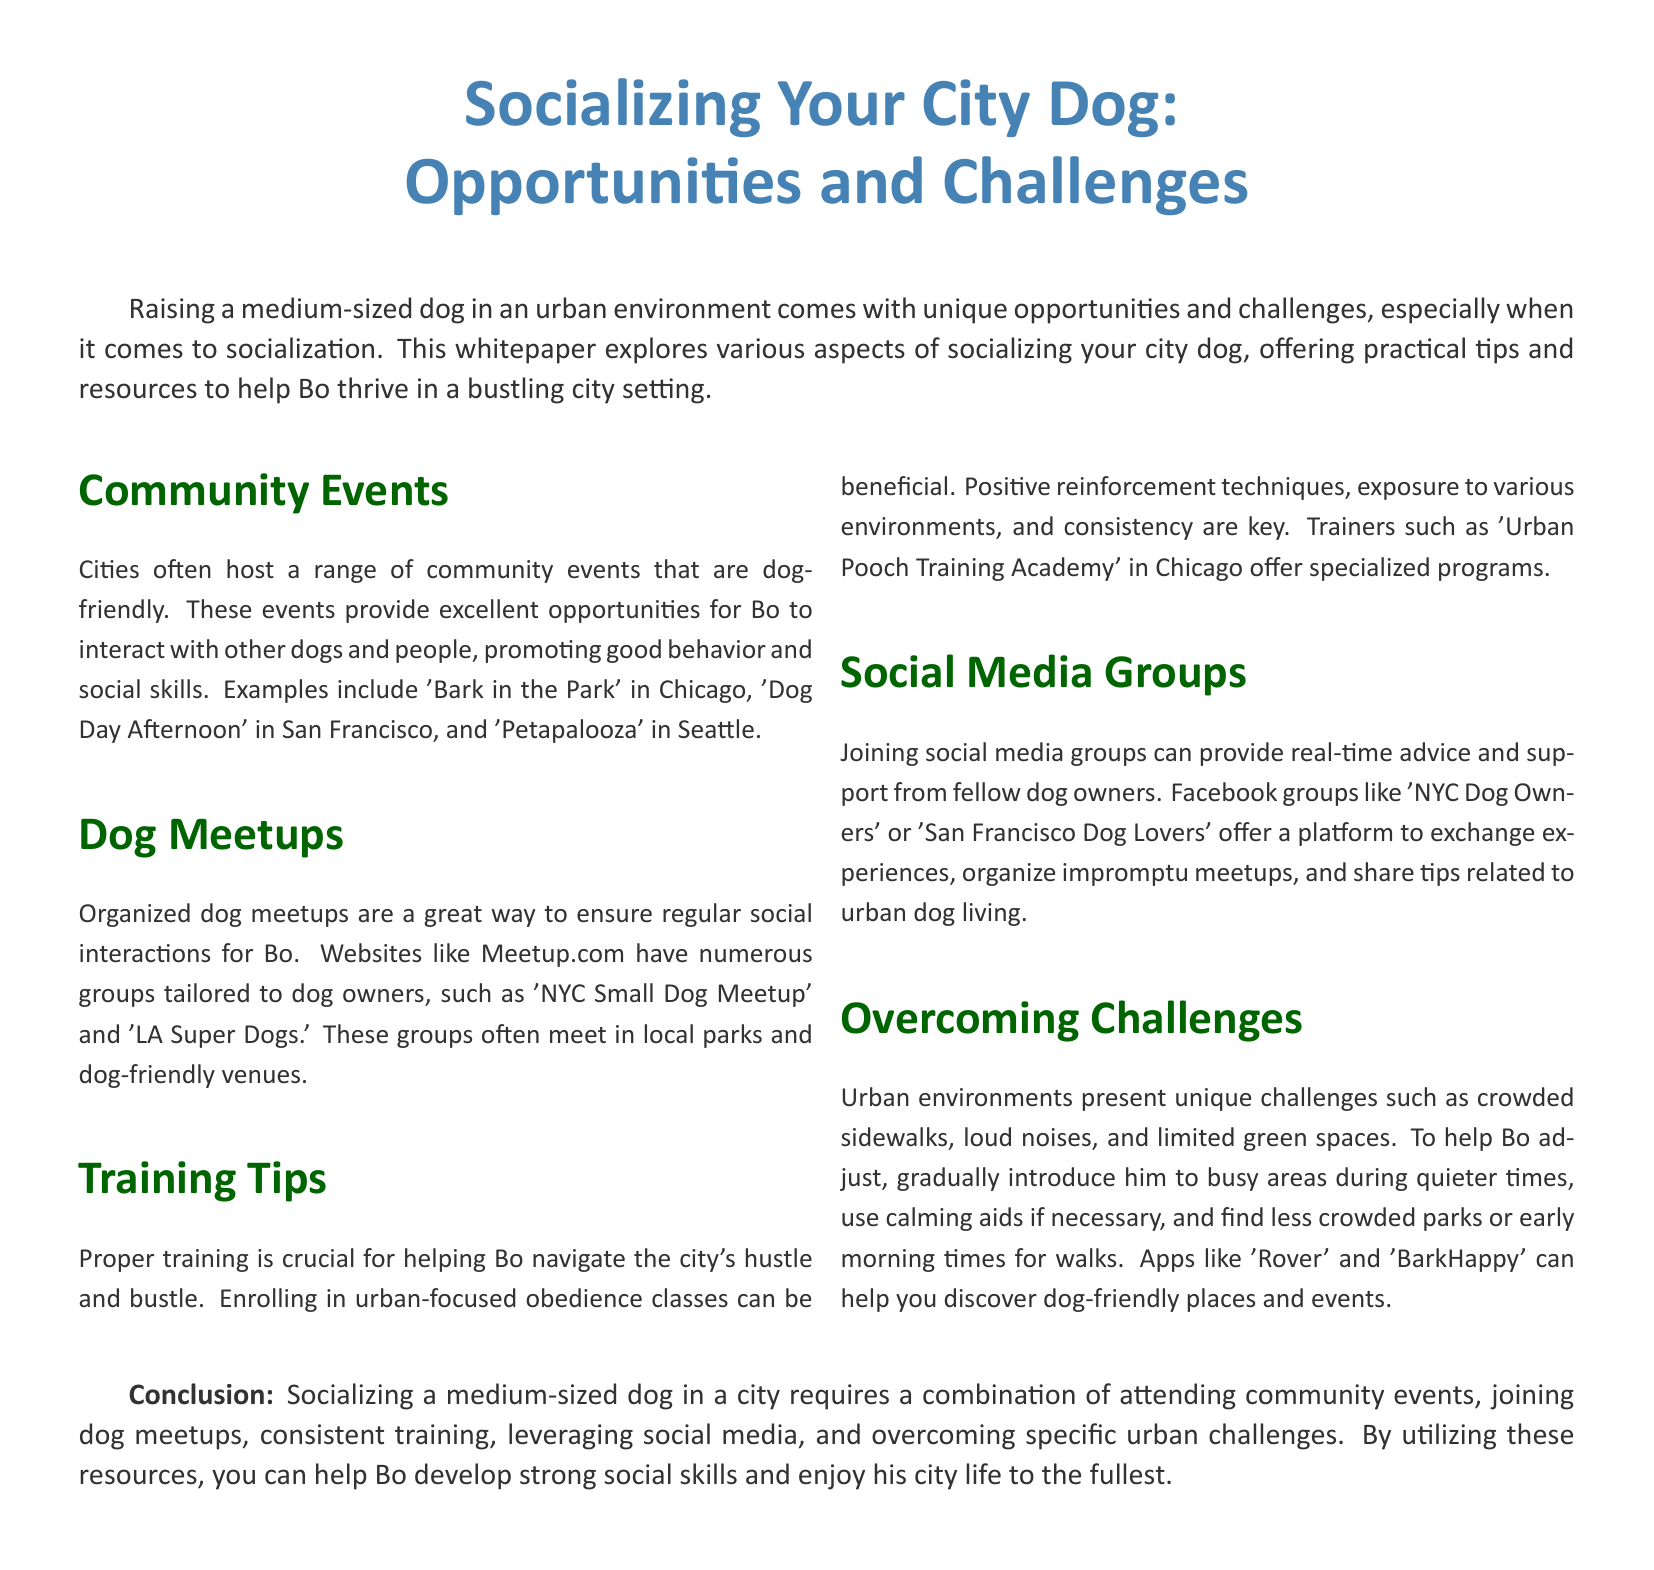what is the title of the whitepaper? The title is prominently displayed at the beginning of the document.
Answer: Socializing Your City Dog: Opportunities and Challenges what are two examples of community events mentioned? The document lists specific events as examples of community involvement.
Answer: Bark in the Park, Dog Day Afternoon what website is suggested for finding dog meetups? The document references a specific website as a resource for organizing dog meetups.
Answer: Meetup.com which training technique is emphasized for urban dog training? The document discusses training methods that are particularly beneficial in an urban setting.
Answer: Positive reinforcement what should you gradually introduce Bo to help him adjust to urban life? The document mentions a strategy for helping dogs acclimate to busy environments.
Answer: Busy areas name a platform for real-time advice among dog owners. The document suggests a specific type of platform for support and communication.
Answer: Facebook groups how can you discover dog-friendly places and events? The document offers applications as a means to explore dog-friendly locations.
Answer: Rover, BarkHappy what is the focus of urban-focused obedience classes? The document outlines the key aspect of these specialized training programs.
Answer: Helping Bo navigate the city's hustle and bustle what is recommended for walks in less crowded areas? The document advises timing strategies for walks in busy environments.
Answer: Early morning times 